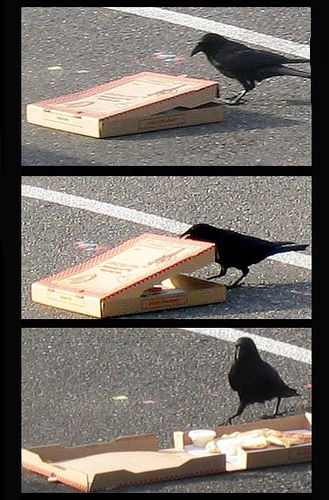Describe the objects in this image and their specific colors. I can see bird in black, gray, and darkgray tones, bird in black and gray tones, bird in black, gray, maroon, and darkgray tones, pizza in black, ivory, and tan tones, and pizza in black, maroon, and gray tones in this image. 